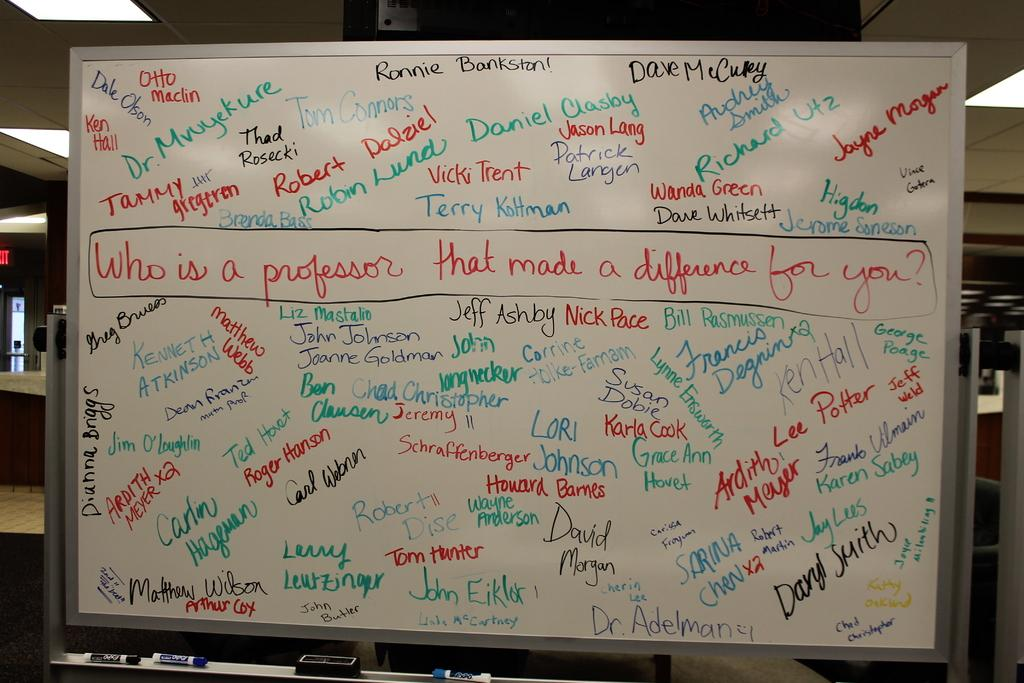<image>
Relay a brief, clear account of the picture shown. White board with a sentence that says "Who is a professor that made a difference for you?" in a box. 